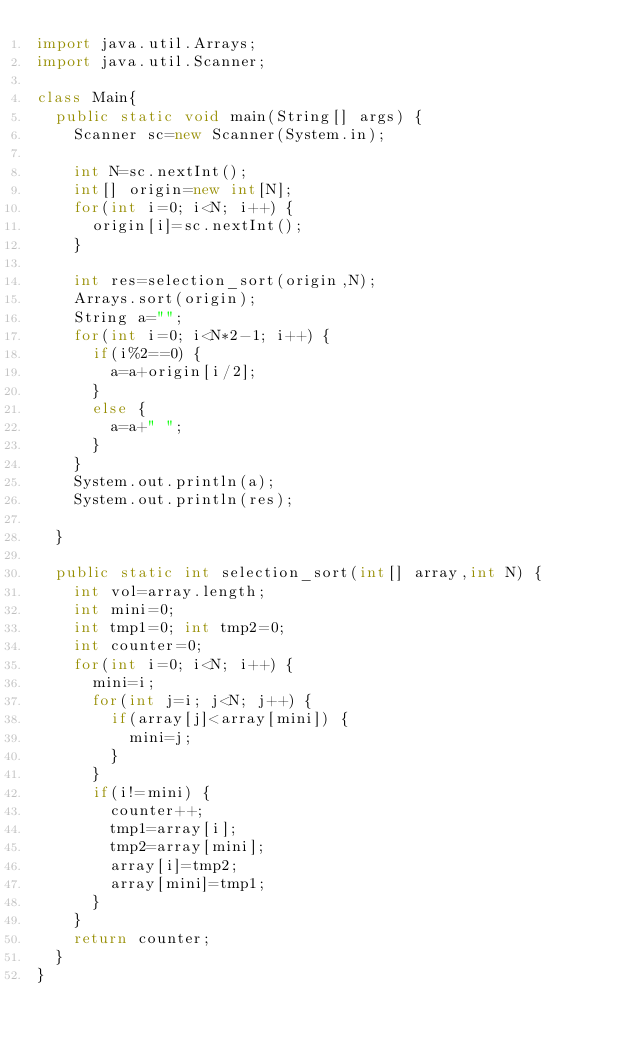<code> <loc_0><loc_0><loc_500><loc_500><_Java_>import java.util.Arrays;
import java.util.Scanner;

class Main{
	public static void main(String[] args) {
		Scanner sc=new Scanner(System.in);

		int N=sc.nextInt();
		int[] origin=new int[N];
		for(int i=0; i<N; i++) {
			origin[i]=sc.nextInt();
		}

		int res=selection_sort(origin,N);
		Arrays.sort(origin);
		String a="";
		for(int i=0; i<N*2-1; i++) {
			if(i%2==0) {
				a=a+origin[i/2];
			}
			else {
				a=a+" ";
			}
		}
		System.out.println(a);
		System.out.println(res);

	}

	public static int selection_sort(int[] array,int N) {
		int vol=array.length;
		int mini=0;
		int tmp1=0; int tmp2=0;
		int counter=0;
		for(int i=0; i<N; i++) {
			mini=i;
			for(int j=i; j<N; j++) {
				if(array[j]<array[mini]) {
					mini=j;
				}
			}
			if(i!=mini) {
				counter++;
				tmp1=array[i];
				tmp2=array[mini];
				array[i]=tmp2;
				array[mini]=tmp1;
			}
		}
		return counter;
	}
}
</code> 